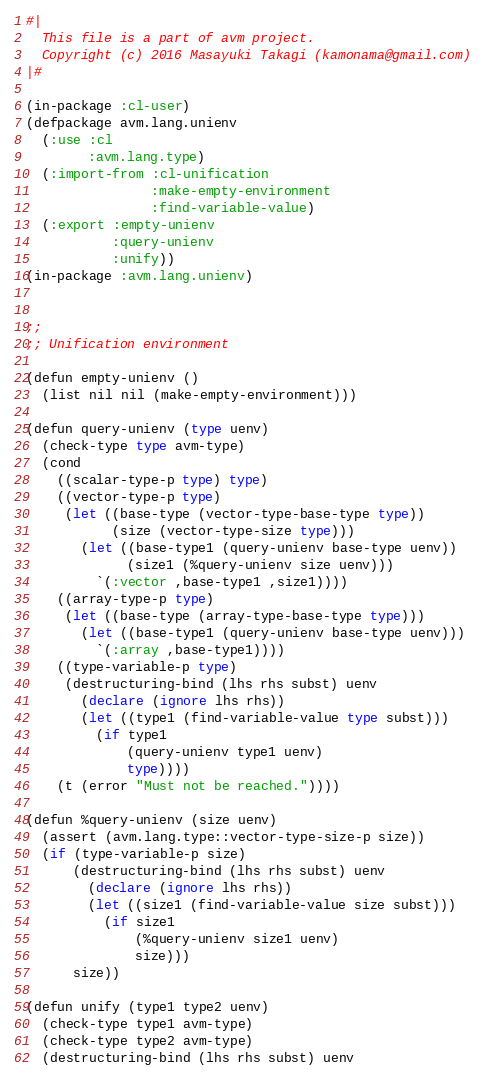Convert code to text. <code><loc_0><loc_0><loc_500><loc_500><_Lisp_>#|
  This file is a part of avm project.
  Copyright (c) 2016 Masayuki Takagi (kamonama@gmail.com)
|#

(in-package :cl-user)
(defpackage avm.lang.unienv
  (:use :cl
        :avm.lang.type)
  (:import-from :cl-unification
                :make-empty-environment
                :find-variable-value)
  (:export :empty-unienv
           :query-unienv
           :unify))
(in-package :avm.lang.unienv)


;;
;; Unification environment

(defun empty-unienv ()
  (list nil nil (make-empty-environment)))

(defun query-unienv (type uenv)
  (check-type type avm-type)
  (cond
    ((scalar-type-p type) type)
    ((vector-type-p type)
     (let ((base-type (vector-type-base-type type))
           (size (vector-type-size type)))
       (let ((base-type1 (query-unienv base-type uenv))
             (size1 (%query-unienv size uenv)))
         `(:vector ,base-type1 ,size1))))
    ((array-type-p type)
     (let ((base-type (array-type-base-type type)))
       (let ((base-type1 (query-unienv base-type uenv)))
         `(:array ,base-type1))))
    ((type-variable-p type)
     (destructuring-bind (lhs rhs subst) uenv
       (declare (ignore lhs rhs))
       (let ((type1 (find-variable-value type subst)))
         (if type1
             (query-unienv type1 uenv)
             type))))
    (t (error "Must not be reached."))))

(defun %query-unienv (size uenv)
  (assert (avm.lang.type::vector-type-size-p size))
  (if (type-variable-p size)
      (destructuring-bind (lhs rhs subst) uenv
        (declare (ignore lhs rhs))
        (let ((size1 (find-variable-value size subst)))
          (if size1
              (%query-unienv size1 uenv)
              size)))
      size))

(defun unify (type1 type2 uenv)
  (check-type type1 avm-type)
  (check-type type2 avm-type)
  (destructuring-bind (lhs rhs subst) uenv</code> 